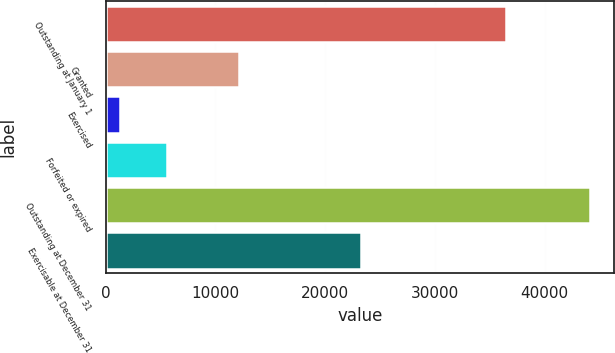<chart> <loc_0><loc_0><loc_500><loc_500><bar_chart><fcel>Outstanding at January 1<fcel>Granted<fcel>Exercised<fcel>Forfeited or expired<fcel>Outstanding at December 31<fcel>Exercisable at December 31<nl><fcel>36502<fcel>12179<fcel>1271<fcel>5555.9<fcel>44120<fcel>23248<nl></chart> 